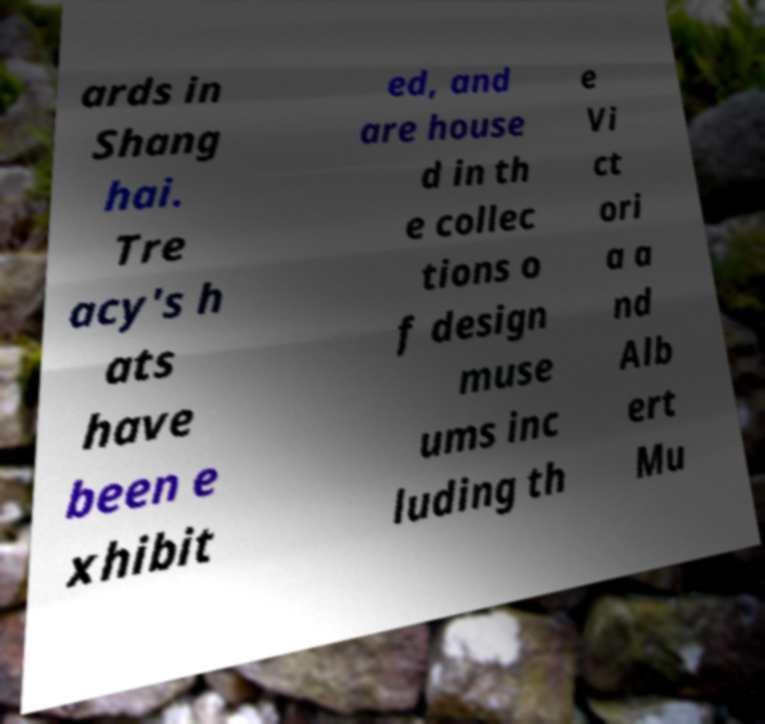I need the written content from this picture converted into text. Can you do that? ards in Shang hai. Tre acy's h ats have been e xhibit ed, and are house d in th e collec tions o f design muse ums inc luding th e Vi ct ori a a nd Alb ert Mu 